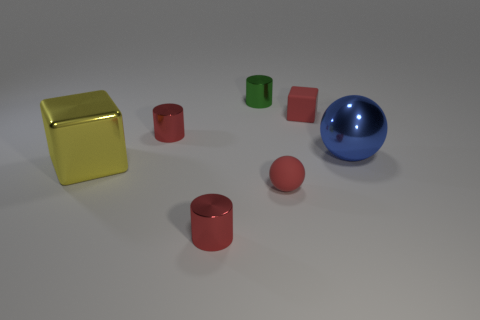Does the small green object have the same shape as the small red metallic thing that is in front of the small red sphere?
Offer a terse response. Yes. What is the size of the other thing that is the same shape as the large blue thing?
Ensure brevity in your answer.  Small. How many other objects are the same material as the small red cube?
Your answer should be compact. 1. What is the material of the large yellow thing?
Provide a short and direct response. Metal. There is a matte thing that is behind the large yellow shiny thing; is it the same color as the small shiny object in front of the tiny red ball?
Make the answer very short. Yes. Are there more balls that are to the right of the red matte block than blue shiny cylinders?
Give a very brief answer. Yes. What number of other things are there of the same color as the matte block?
Keep it short and to the point. 3. There is a red shiny thing that is behind the blue object; is it the same size as the big blue thing?
Provide a succinct answer. No. Is there a matte object of the same size as the green shiny thing?
Your response must be concise. Yes. What is the color of the large thing right of the rubber block?
Offer a terse response. Blue. 